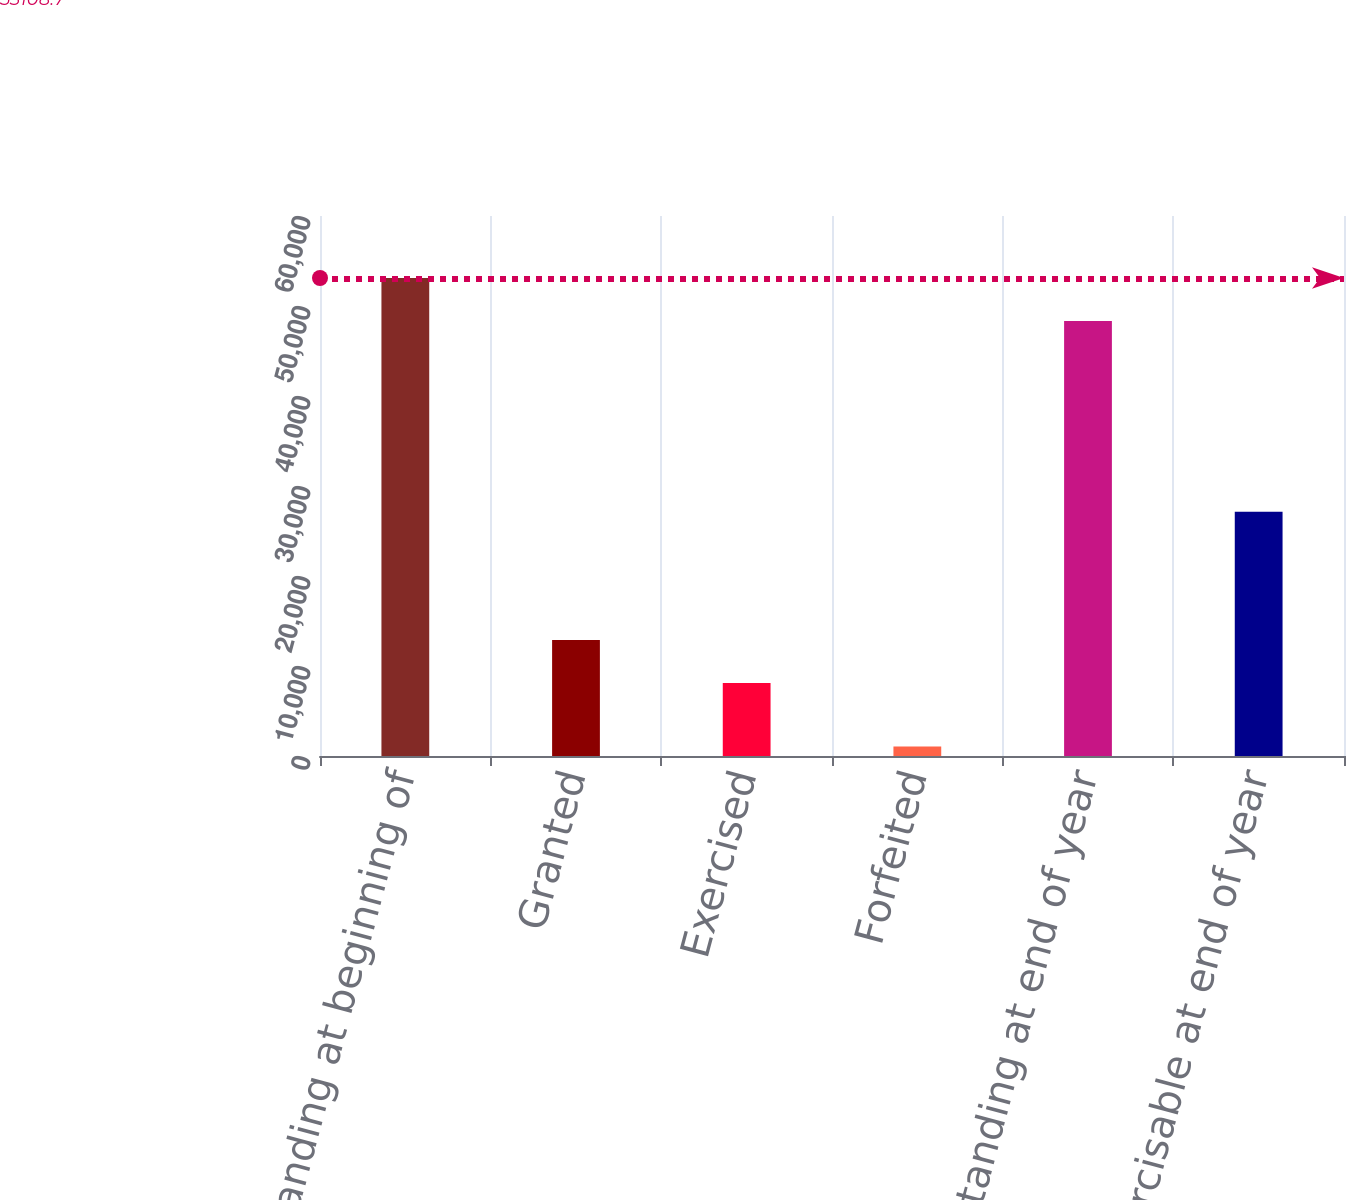Convert chart. <chart><loc_0><loc_0><loc_500><loc_500><bar_chart><fcel>Outstanding at beginning of<fcel>Granted<fcel>Exercised<fcel>Forfeited<fcel>Outstanding at end of year<fcel>Exercisable at end of year<nl><fcel>53108.7<fcel>12879.7<fcel>8108<fcel>1055<fcel>48337<fcel>27126<nl></chart> 